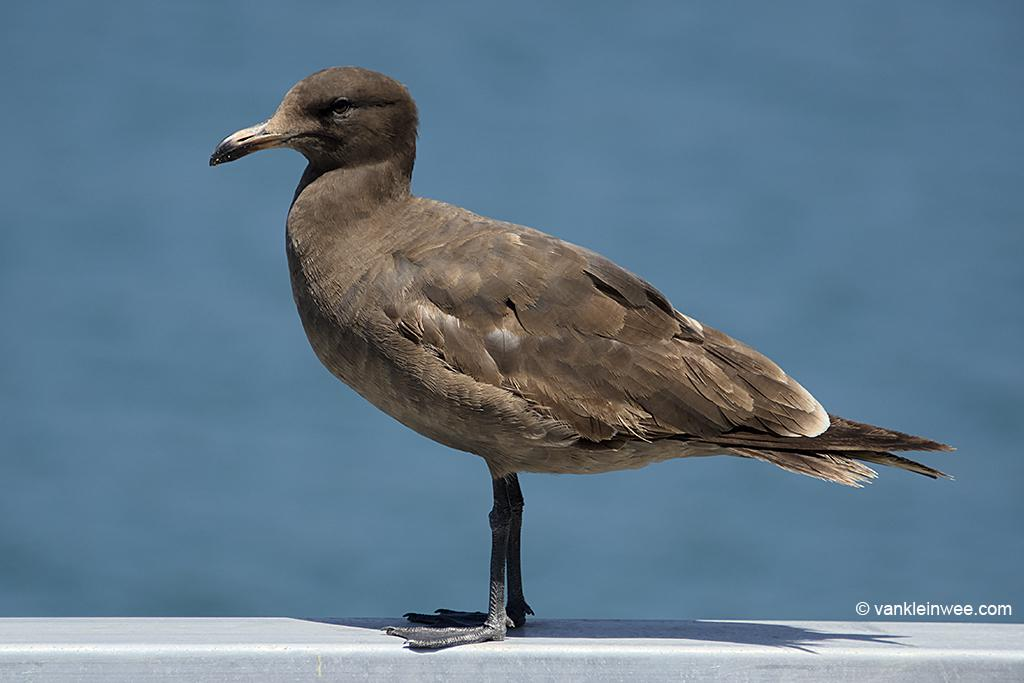What type of animal is in the image? There is a bird in the image. What color is the bird? The bird is brown in color. What are some features of the bird? The bird has an eye and a beak. What can be seen in the background of the image? The background of the image is blue. How does the bird rule over its kingdom in the image? There is no indication in the image that the bird is ruling over a kingdom or has any authority. 